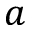<formula> <loc_0><loc_0><loc_500><loc_500>a</formula> 